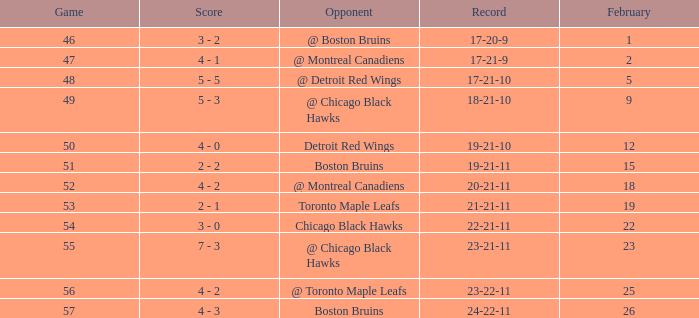What was the score of the game 57 after February 23? 4 - 3. 